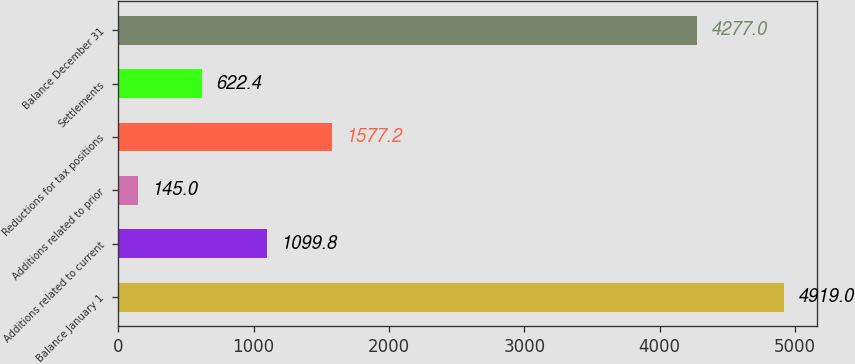Convert chart to OTSL. <chart><loc_0><loc_0><loc_500><loc_500><bar_chart><fcel>Balance January 1<fcel>Additions related to current<fcel>Additions related to prior<fcel>Reductions for tax positions<fcel>Settlements<fcel>Balance December 31<nl><fcel>4919<fcel>1099.8<fcel>145<fcel>1577.2<fcel>622.4<fcel>4277<nl></chart> 